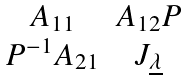Convert formula to latex. <formula><loc_0><loc_0><loc_500><loc_500>\begin{matrix} A _ { 1 1 } & A _ { 1 2 } P \\ P ^ { - 1 } A _ { 2 1 } & J _ { \underline { \lambda } } \end{matrix}</formula> 